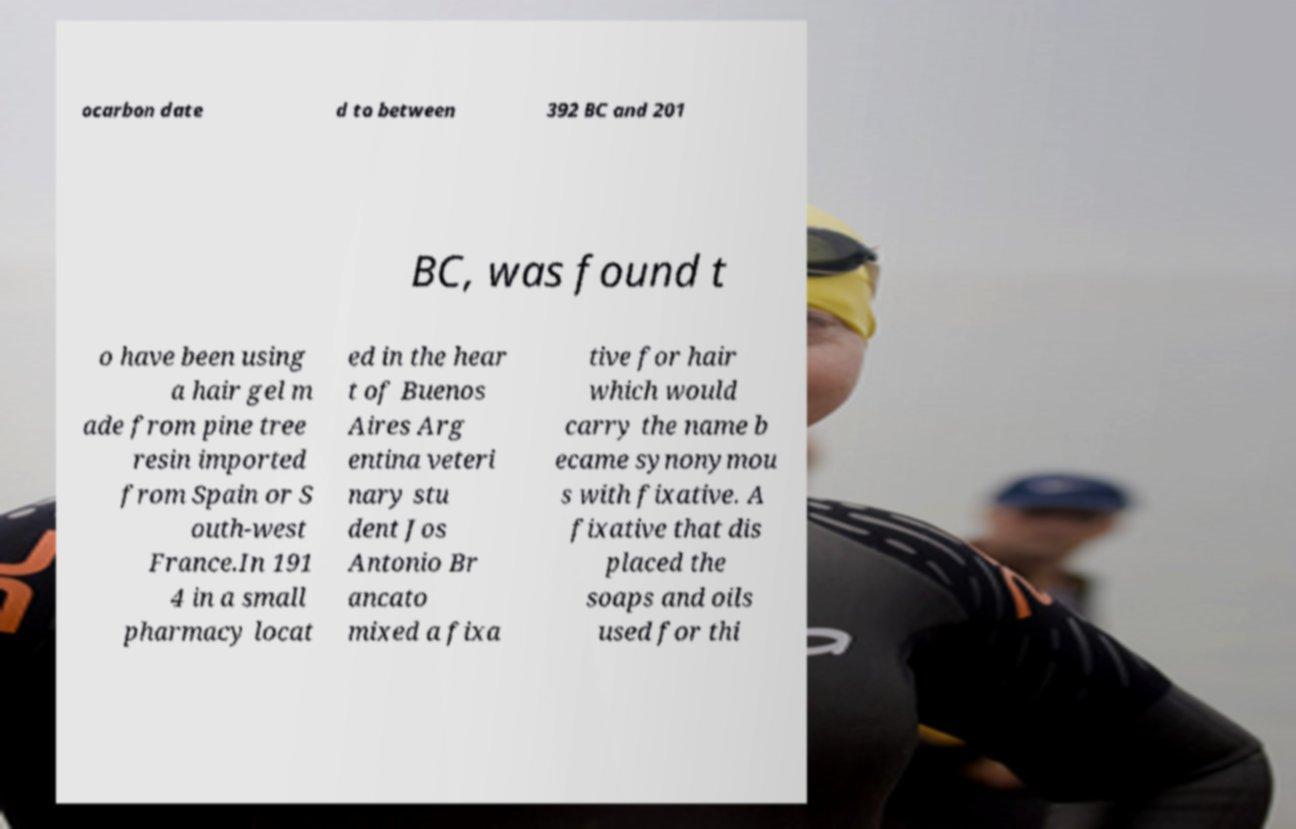Could you extract and type out the text from this image? ocarbon date d to between 392 BC and 201 BC, was found t o have been using a hair gel m ade from pine tree resin imported from Spain or S outh-west France.In 191 4 in a small pharmacy locat ed in the hear t of Buenos Aires Arg entina veteri nary stu dent Jos Antonio Br ancato mixed a fixa tive for hair which would carry the name b ecame synonymou s with fixative. A fixative that dis placed the soaps and oils used for thi 